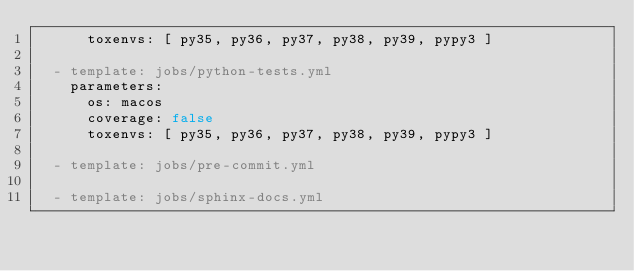Convert code to text. <code><loc_0><loc_0><loc_500><loc_500><_YAML_>      toxenvs: [ py35, py36, py37, py38, py39, pypy3 ]

  - template: jobs/python-tests.yml
    parameters:
      os: macos
      coverage: false
      toxenvs: [ py35, py36, py37, py38, py39, pypy3 ]

  - template: jobs/pre-commit.yml

  - template: jobs/sphinx-docs.yml
</code> 